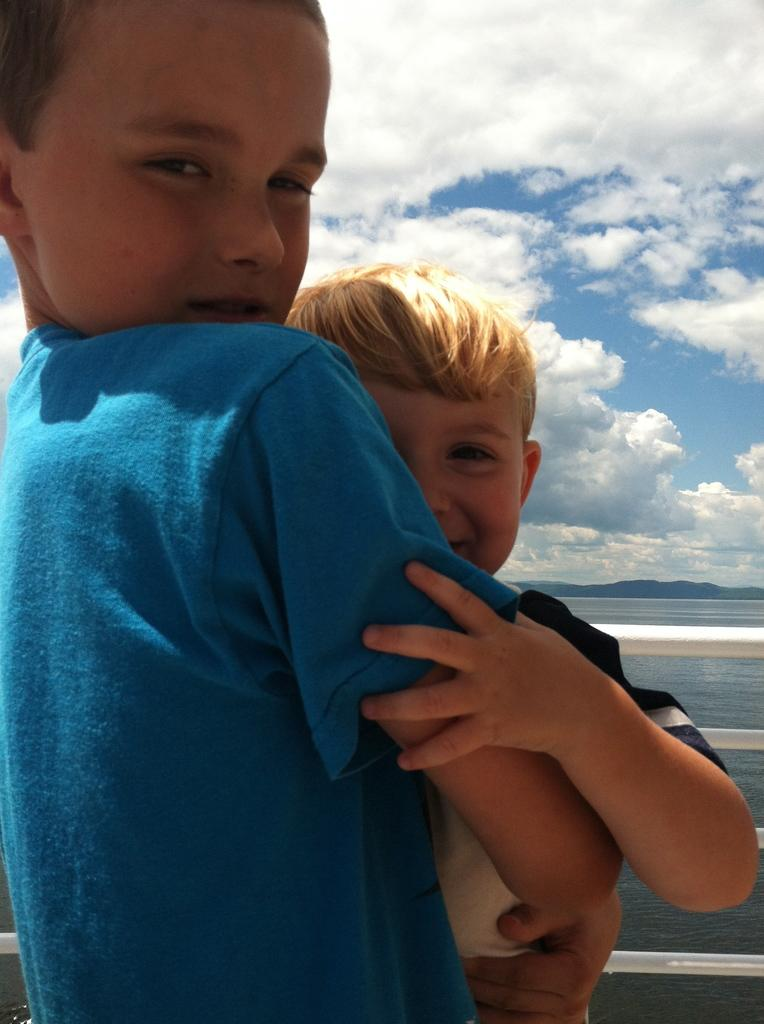How many children are in the image? There are two children in the center of the image. What can be seen in the background of the image? There is water visible in the background of the image. What type of string is being used by the children in the image? There is no string present in the image; the children are not using any string. 